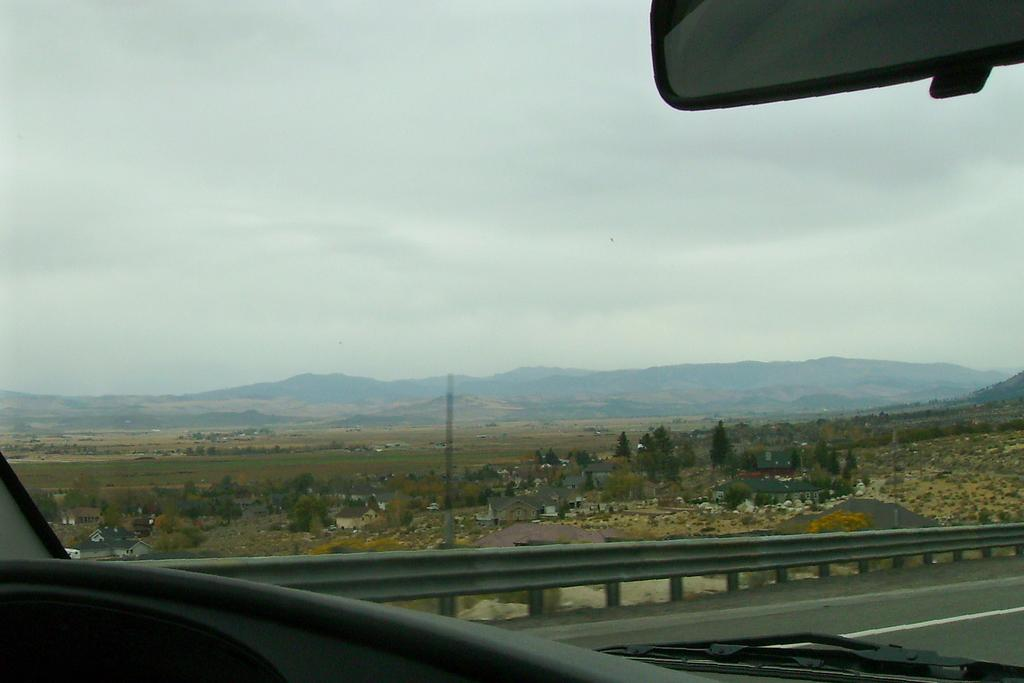What type of vehicle is depicted in the image? The image shows a glass of a vehicle, but it does not specify the type of vehicle. What can be seen in the background of the image? There are trees visible in the image. What is visible at the top of the image? The sky is visible at the top of the image. What musical instrument is being played in the image? There is no musical instrument or indication of music being played in the image. 